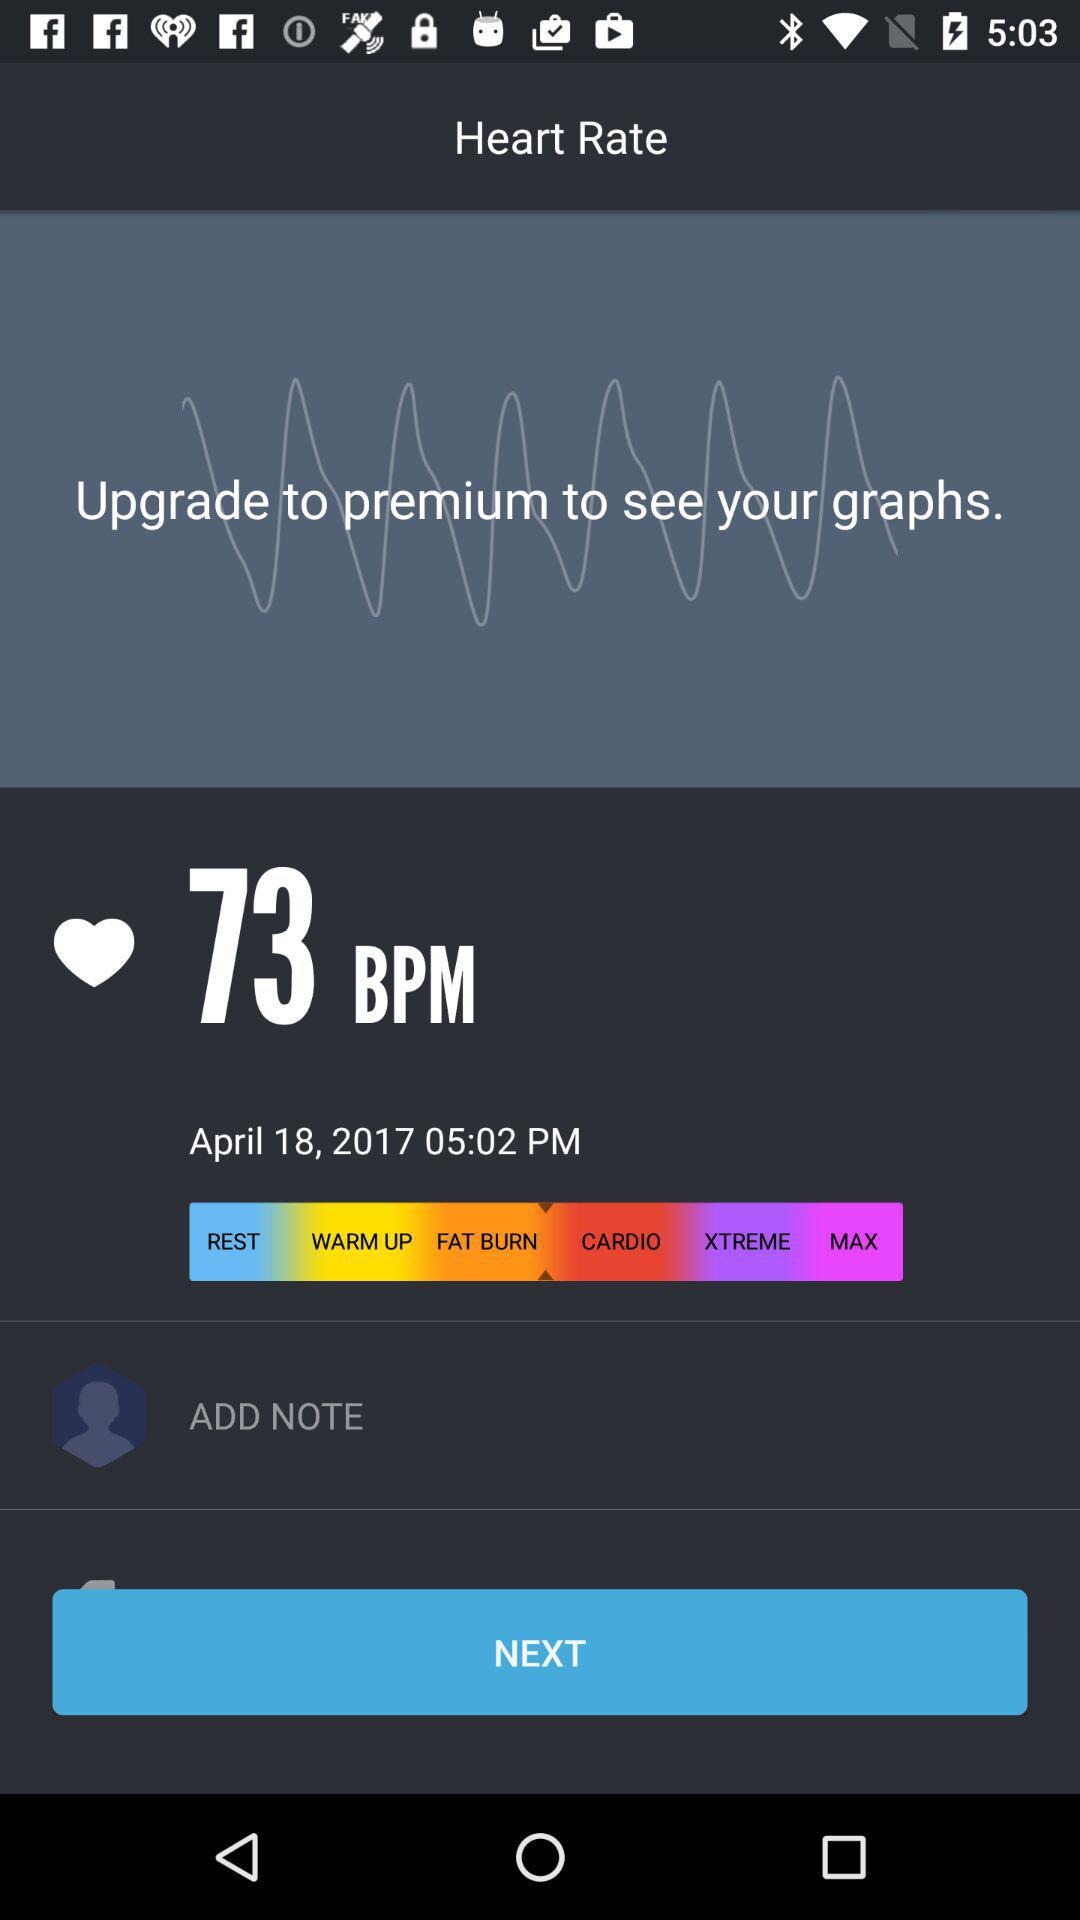What is the date and time? The date is April 18, 2017 and the time is 05:02 PM. 